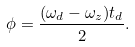<formula> <loc_0><loc_0><loc_500><loc_500>\phi = \frac { ( \omega _ { d } - \omega _ { z } ) t _ { d } } { 2 } .</formula> 